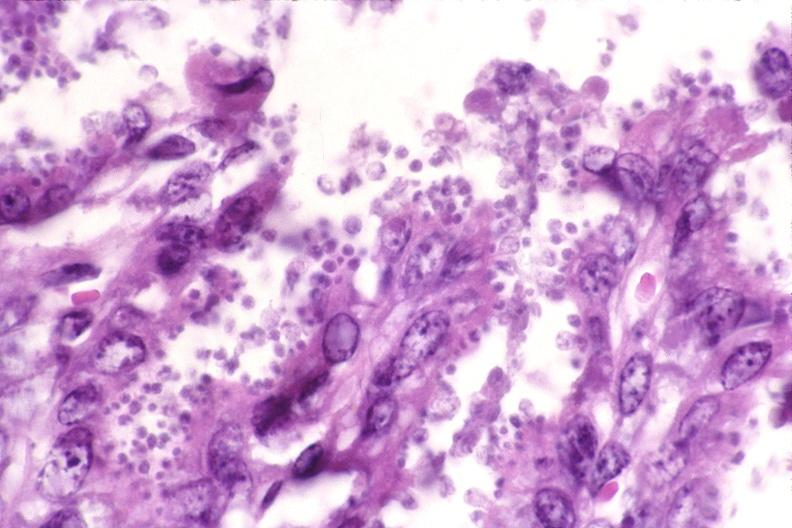s gastrointestinal present?
Answer the question using a single word or phrase. Yes 